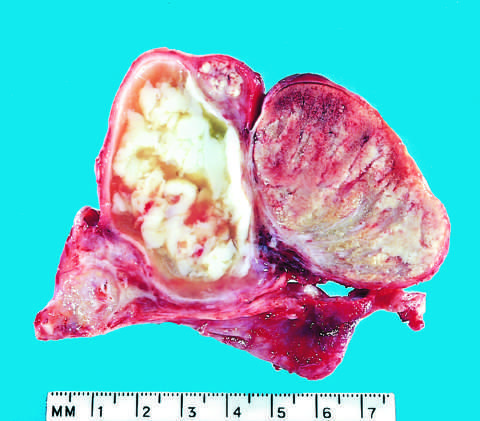s the epididymis involved by an abscess?
Answer the question using a single word or phrase. Yes 